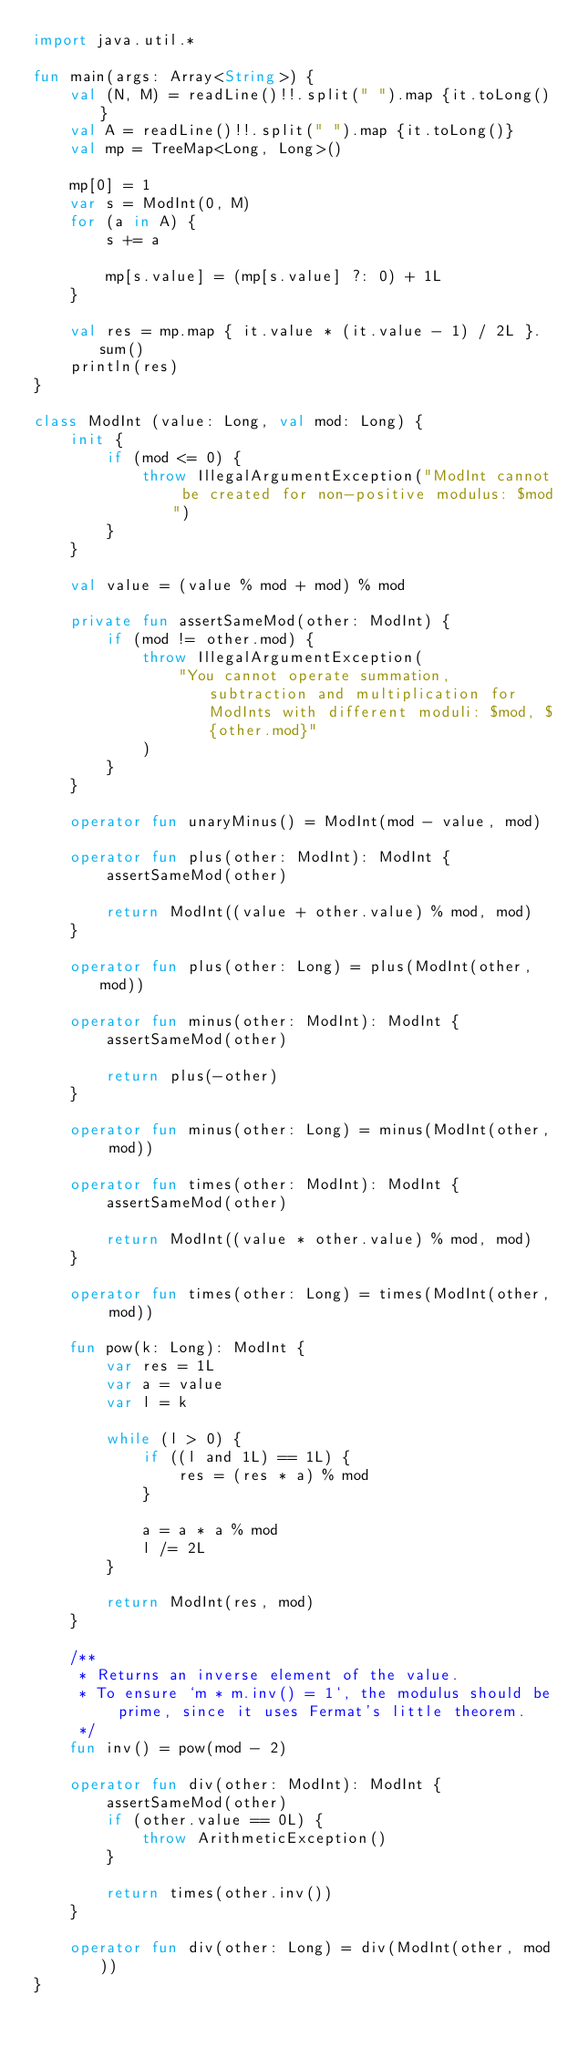Convert code to text. <code><loc_0><loc_0><loc_500><loc_500><_Kotlin_>import java.util.*

fun main(args: Array<String>) {
    val (N, M) = readLine()!!.split(" ").map {it.toLong()}
    val A = readLine()!!.split(" ").map {it.toLong()}
    val mp = TreeMap<Long, Long>()

    mp[0] = 1
    var s = ModInt(0, M)
    for (a in A) {
        s += a

        mp[s.value] = (mp[s.value] ?: 0) + 1L
    }

    val res = mp.map { it.value * (it.value - 1) / 2L }.sum()
    println(res)
}

class ModInt (value: Long, val mod: Long) {
    init {
        if (mod <= 0) {
            throw IllegalArgumentException("ModInt cannot be created for non-positive modulus: $mod")
        }
    }

    val value = (value % mod + mod) % mod

    private fun assertSameMod(other: ModInt) {
        if (mod != other.mod) {
            throw IllegalArgumentException(
                "You cannot operate summation, subtraction and multiplication for ModInts with different moduli: $mod, ${other.mod}"
            )
        }
    }

    operator fun unaryMinus() = ModInt(mod - value, mod)

    operator fun plus(other: ModInt): ModInt {
        assertSameMod(other)

        return ModInt((value + other.value) % mod, mod)
    }

    operator fun plus(other: Long) = plus(ModInt(other, mod))

    operator fun minus(other: ModInt): ModInt {
        assertSameMod(other)

        return plus(-other)
    }

    operator fun minus(other: Long) = minus(ModInt(other, mod))

    operator fun times(other: ModInt): ModInt {
        assertSameMod(other)

        return ModInt((value * other.value) % mod, mod)
    }

    operator fun times(other: Long) = times(ModInt(other, mod))

    fun pow(k: Long): ModInt {
        var res = 1L
        var a = value
        var l = k

        while (l > 0) {
            if ((l and 1L) == 1L) {
                res = (res * a) % mod
            }

            a = a * a % mod
            l /= 2L
        }

        return ModInt(res, mod)
    }

    /**
     * Returns an inverse element of the value.
     * To ensure `m * m.inv() = 1`, the modulus should be prime, since it uses Fermat's little theorem.
     */
    fun inv() = pow(mod - 2)

    operator fun div(other: ModInt): ModInt {
        assertSameMod(other)
        if (other.value == 0L) {
            throw ArithmeticException()
        }

        return times(other.inv())
    }

    operator fun div(other: Long) = div(ModInt(other, mod))
}
</code> 